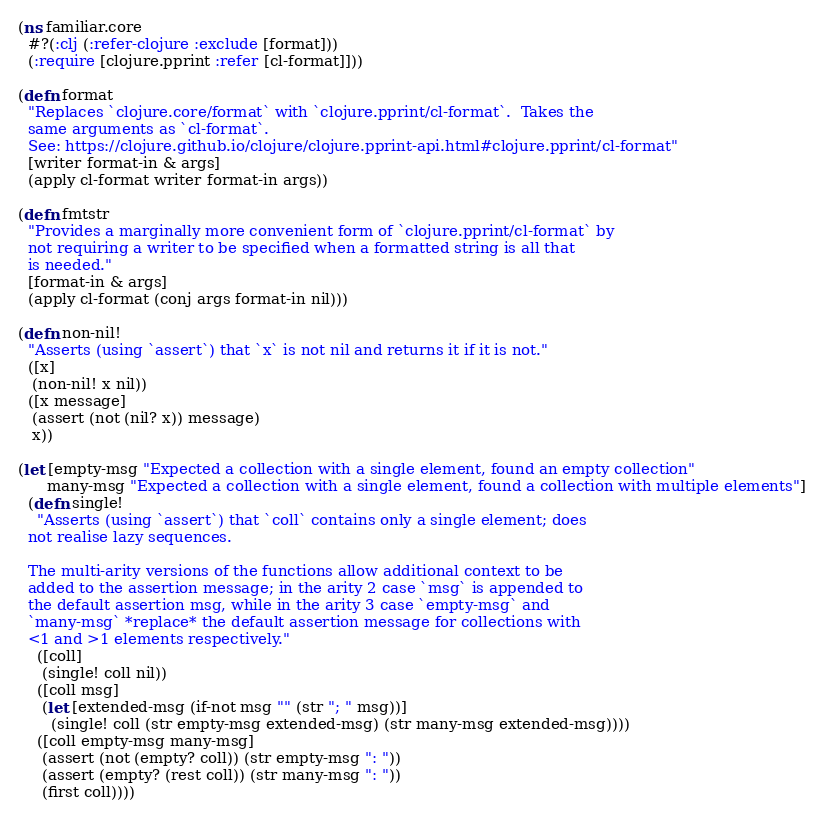Convert code to text. <code><loc_0><loc_0><loc_500><loc_500><_Clojure_>
(ns familiar.core
  #?(:clj (:refer-clojure :exclude [format]))
  (:require [clojure.pprint :refer [cl-format]]))

(defn format
  "Replaces `clojure.core/format` with `clojure.pprint/cl-format`.  Takes the
  same arguments as `cl-format`.
  See: https://clojure.github.io/clojure/clojure.pprint-api.html#clojure.pprint/cl-format"
  [writer format-in & args]
  (apply cl-format writer format-in args))

(defn fmtstr
  "Provides a marginally more convenient form of `clojure.pprint/cl-format` by
  not requiring a writer to be specified when a formatted string is all that
  is needed."
  [format-in & args]
  (apply cl-format (conj args format-in nil)))

(defn non-nil!
  "Asserts (using `assert`) that `x` is not nil and returns it if it is not."
  ([x]
   (non-nil! x nil))
  ([x message]
   (assert (not (nil? x)) message)
   x))

(let [empty-msg "Expected a collection with a single element, found an empty collection"
      many-msg "Expected a collection with a single element, found a collection with multiple elements"]
  (defn single!
    "Asserts (using `assert`) that `coll` contains only a single element; does
  not realise lazy sequences.

  The multi-arity versions of the functions allow additional context to be
  added to the assertion message; in the arity 2 case `msg` is appended to
  the default assertion msg, while in the arity 3 case `empty-msg` and
  `many-msg` *replace* the default assertion message for collections with
  <1 and >1 elements respectively."
    ([coll]
     (single! coll nil))
    ([coll msg]
     (let [extended-msg (if-not msg "" (str "; " msg))]
       (single! coll (str empty-msg extended-msg) (str many-msg extended-msg))))
    ([coll empty-msg many-msg]
     (assert (not (empty? coll)) (str empty-msg ": "))
     (assert (empty? (rest coll)) (str many-msg ": "))
     (first coll))))
</code> 